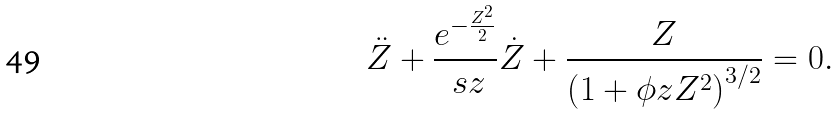<formula> <loc_0><loc_0><loc_500><loc_500>\ddot { Z } + \frac { e ^ { - \frac { Z ^ { 2 } } { 2 } } } { \ s z } \dot { Z } + \frac { Z } { \left ( 1 + \phi z Z ^ { 2 } \right ) ^ { 3 / 2 } } = 0 .</formula> 